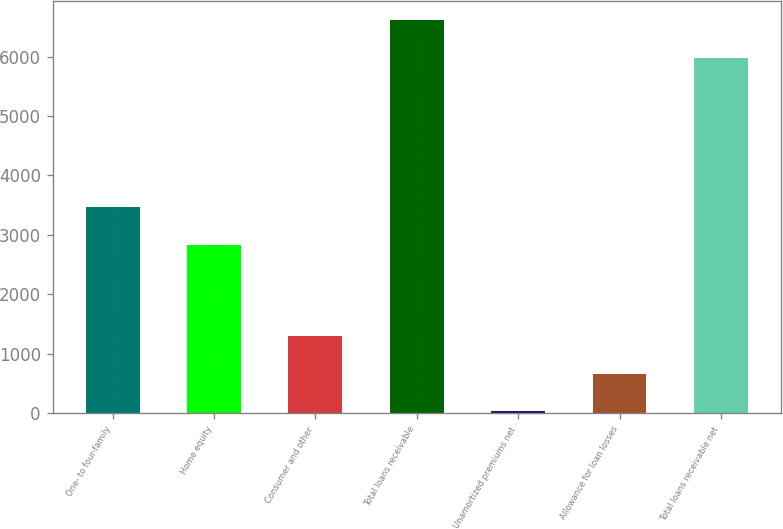Convert chart. <chart><loc_0><loc_0><loc_500><loc_500><bar_chart><fcel>One- to four-family<fcel>Home equity<fcel>Consumer and other<fcel>Total loans receivable<fcel>Unamortized premiums net<fcel>Allowance for loan losses<fcel>Total loans receivable net<nl><fcel>3465.5<fcel>2834<fcel>1297<fcel>6610.5<fcel>34<fcel>665.5<fcel>5979<nl></chart> 